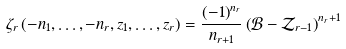Convert formula to latex. <formula><loc_0><loc_0><loc_500><loc_500>\zeta _ { r } \left ( - n _ { 1 } , \dots , - n _ { r } , z _ { 1 } , \dots , z _ { r } \right ) = \frac { \left ( - 1 \right ) ^ { n _ { r } } } { n _ { r + 1 } } \left ( \mathcal { B } - \mathcal { Z } _ { r - 1 } \right ) ^ { n _ { r } + 1 }</formula> 